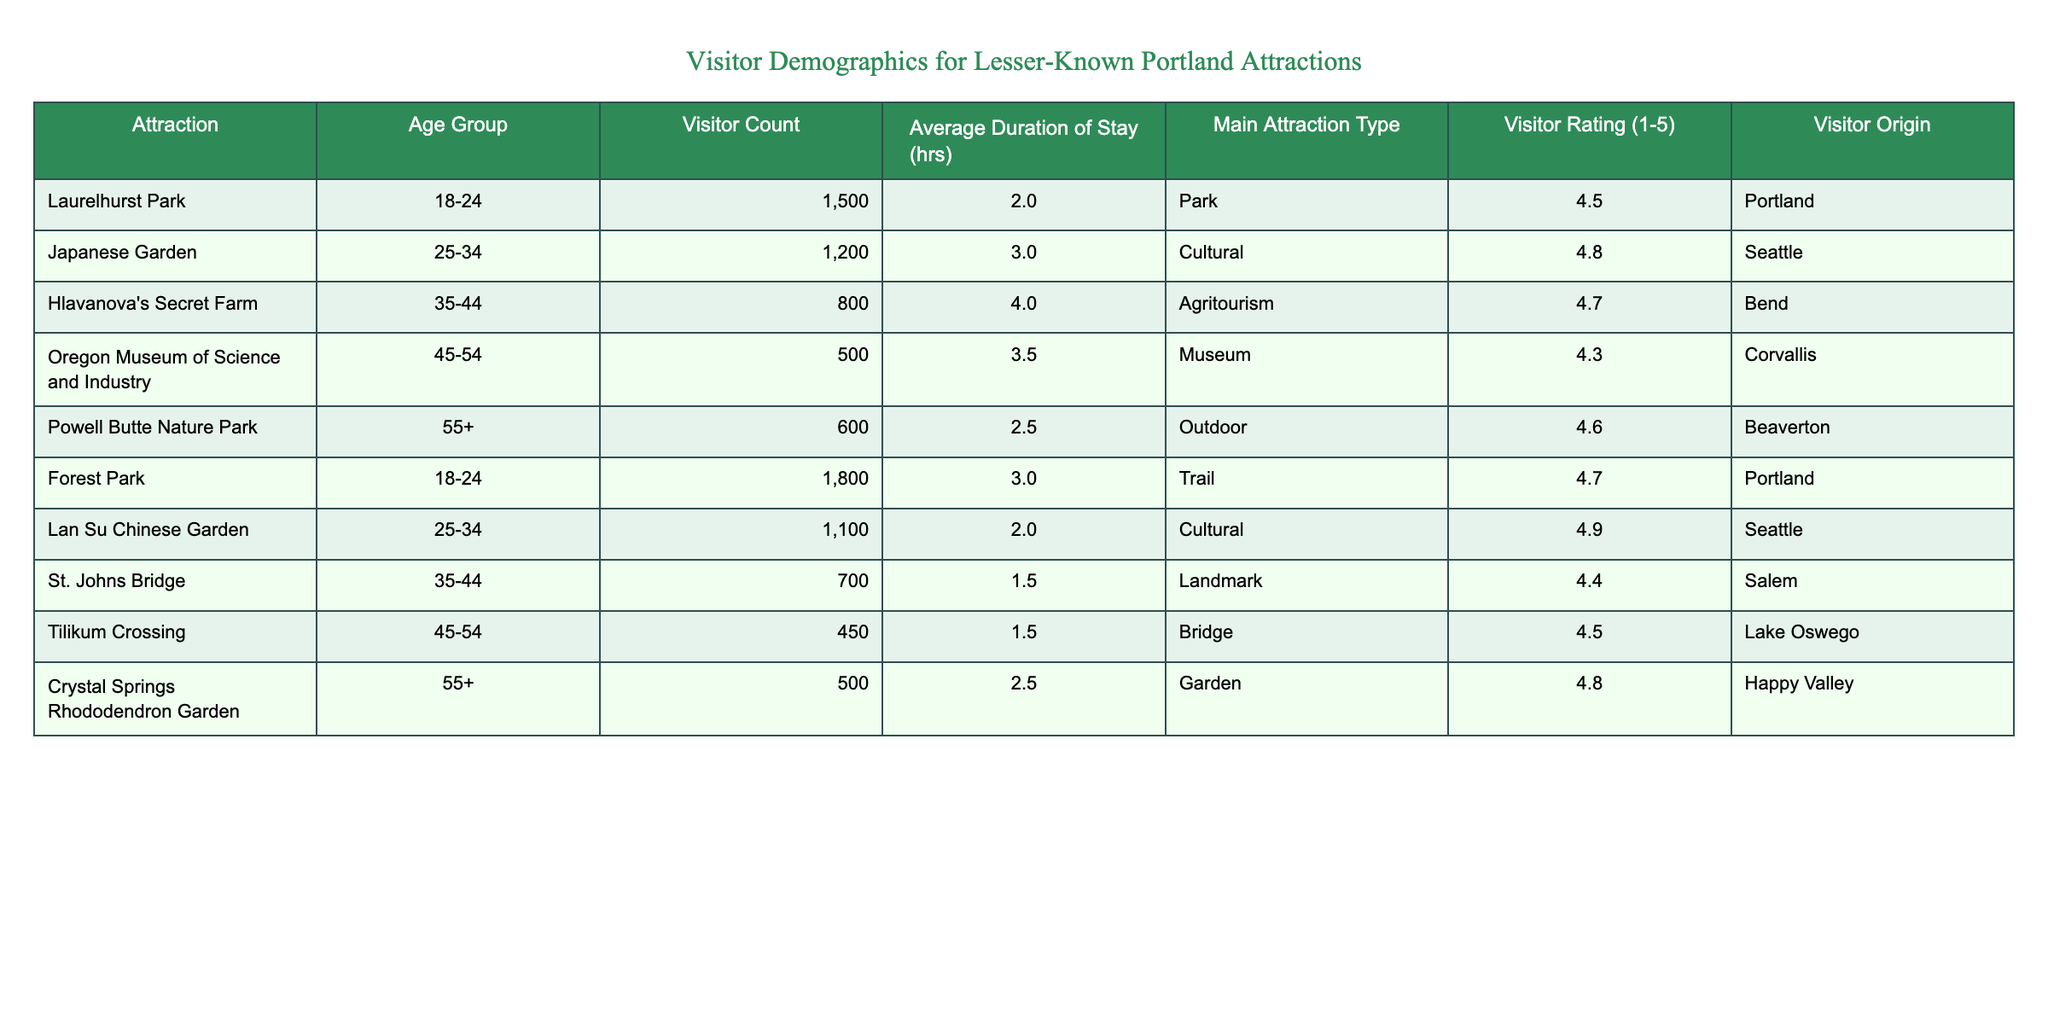What is the visitor count for the Japanese Garden? The Japanese Garden is listed in the table, and the corresponding visitor count is 1200.
Answer: 1200 What is the average duration of stay for visitors at Hlavanova's Secret Farm? The average duration of stay for Hlavanova's Secret Farm in the table is 4 hours, which is explicitly provided in the respective row.
Answer: 4 Which attraction has the highest visitor rating? By examining the Visitor Rating column, the highest rating is 4.9 for Lan Su Chinese Garden, which stands out from the other ratings presented.
Answer: 4.9 How many visitors came from Portland to Laurelhurst Park and Forest Park combined? The visitor counts for Laurelhurst Park (1500) and Forest Park (1800) need to be added together: 1500 + 1800 = 3300, which gives the total visitor count from Portland to these two attractions.
Answer: 3300 Is the average stay at Powell Butte Nature Park greater than that at Crystal Springs Rhododendron Garden? The average duration at Powell Butte Nature Park is 2.5 hours, while at Crystal Springs Rhododendron Garden, it's also 2.5 hours, so both averages are equal to each other, resulting in a "No" answer.
Answer: No What percentage of the total visitor count is made up of visitors aged 35-44? The total visitor count across all attractions is 4900 (1500 + 1200 + 800 + 500 + 600 + 1800 + 1100 + 700 + 450 + 500), while visitors aged 35-44 comprise 800 (from Hlavanova's Secret Farm) + 700 (from St. Johns Bridge) = 1500. The percentage is (1500/4900) * 100, which calculates to approximately 30.61%.
Answer: 30.61% What is the overall average rating of attractions that have visitors primarily from Portland? Only Laurelhurst Park (4.5) and Forest Park (4.7) have Portland as the visitor origin. They have ratings of 4.5 and 4.7 respectively. The average rating is calculated as (4.5 + 4.7) / 2 = 4.6.
Answer: 4.6 Does the average duration of stay at the Oregon Museum of Science and Industry exceed 3.5 hours? The average duration of stay at the Oregon Museum of Science and Industry is 3.5 hours, which does not exceed 3.5 hours; hence the answer is "No."
Answer: No 